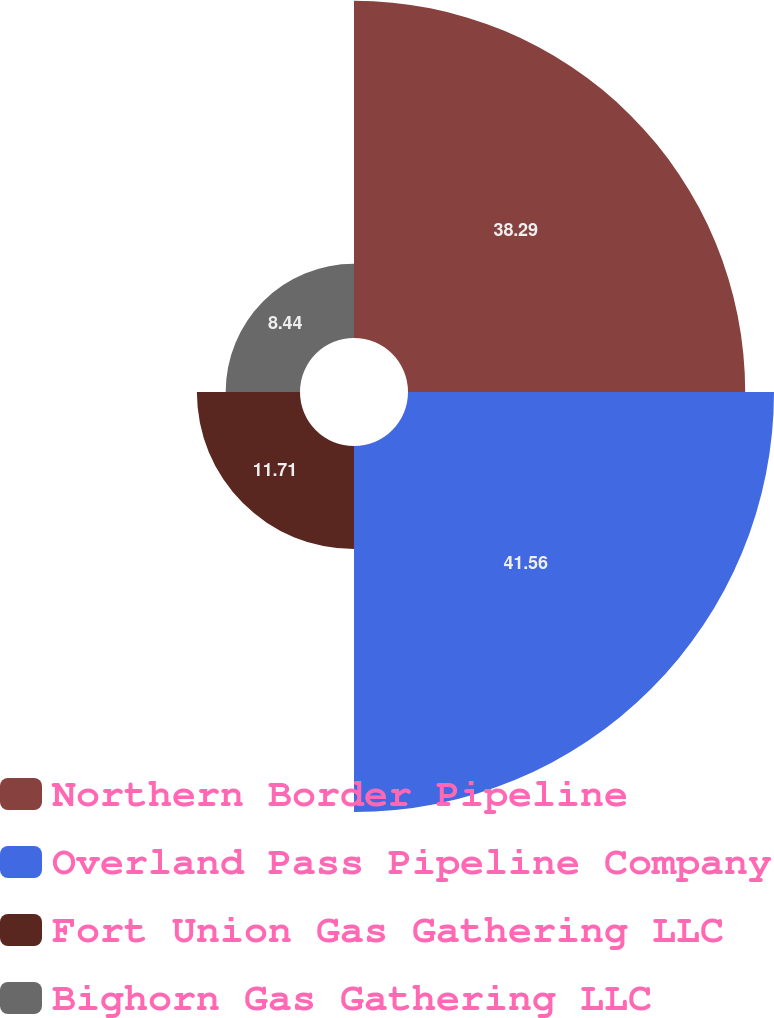Convert chart. <chart><loc_0><loc_0><loc_500><loc_500><pie_chart><fcel>Northern Border Pipeline<fcel>Overland Pass Pipeline Company<fcel>Fort Union Gas Gathering LLC<fcel>Bighorn Gas Gathering LLC<nl><fcel>38.29%<fcel>41.56%<fcel>11.71%<fcel>8.44%<nl></chart> 